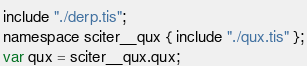Convert code to text. <code><loc_0><loc_0><loc_500><loc_500><_JavaScript_>include "./derp.tis";
namespace sciter__qux { include "./qux.tis" };
var qux = sciter__qux.qux;
</code> 